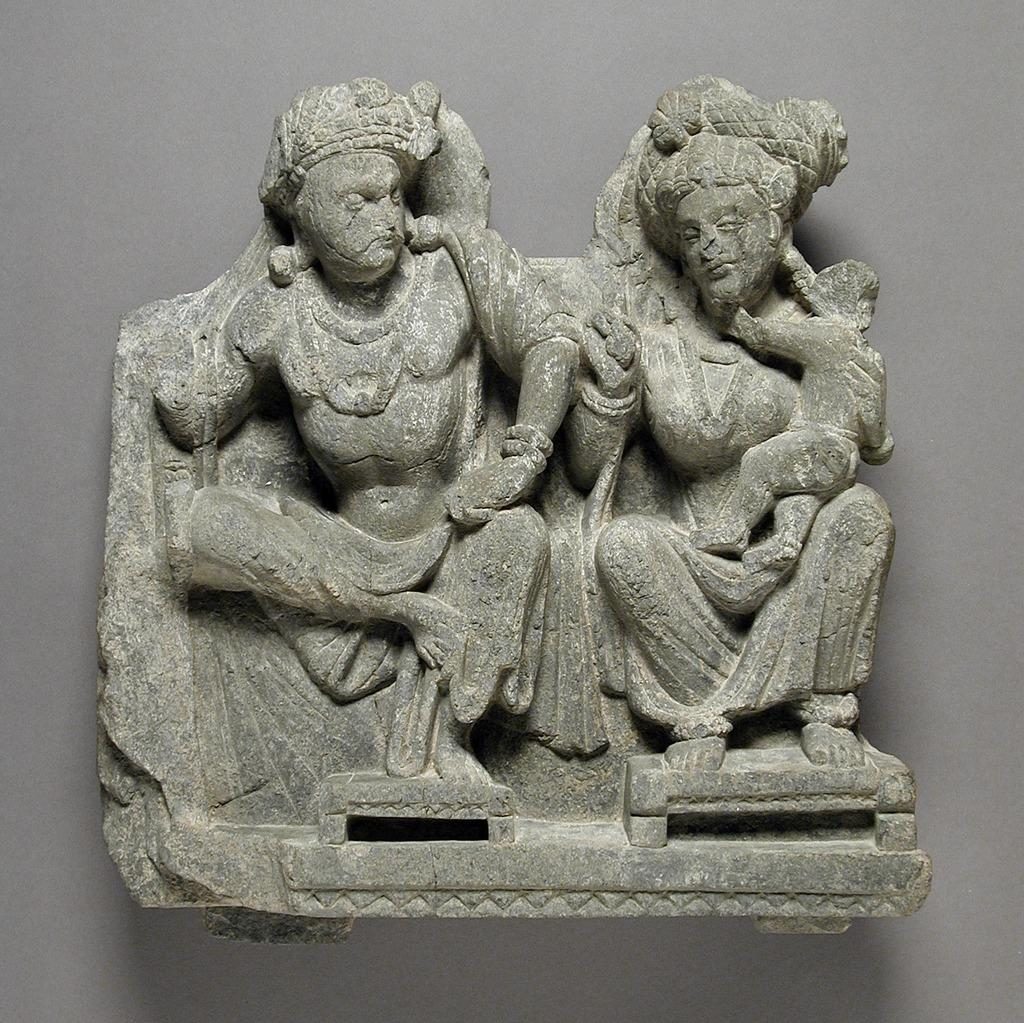What is the main subject of the image? The main subject of the image is a statue. Where is the statue located in relation to the wall? The statue is attached to a wall. What type of engine is powering the statue in the image? There is no engine present in the image, as the statue is stationary and attached to a wall. 